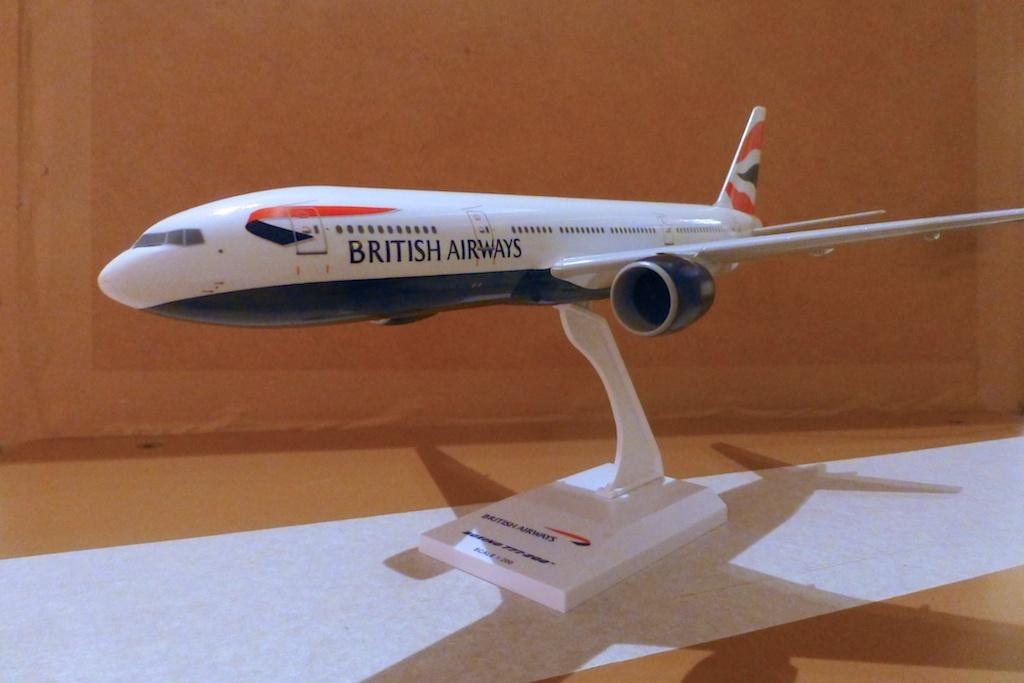<image>
Present a compact description of the photo's key features. the british airways airplane model is sitting on a stand 